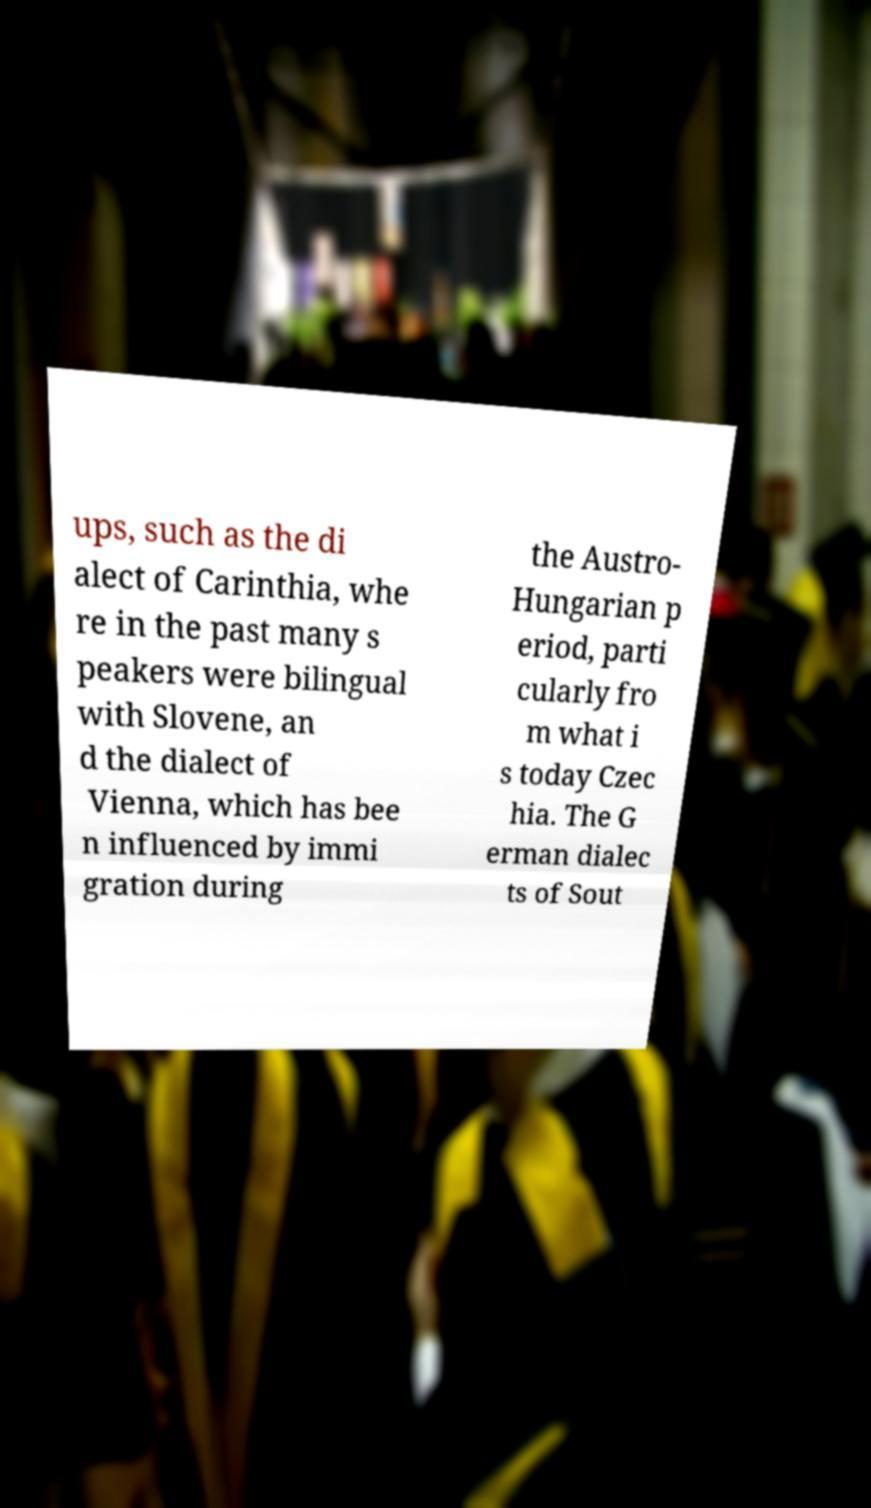Could you assist in decoding the text presented in this image and type it out clearly? ups, such as the di alect of Carinthia, whe re in the past many s peakers were bilingual with Slovene, an d the dialect of Vienna, which has bee n influenced by immi gration during the Austro- Hungarian p eriod, parti cularly fro m what i s today Czec hia. The G erman dialec ts of Sout 